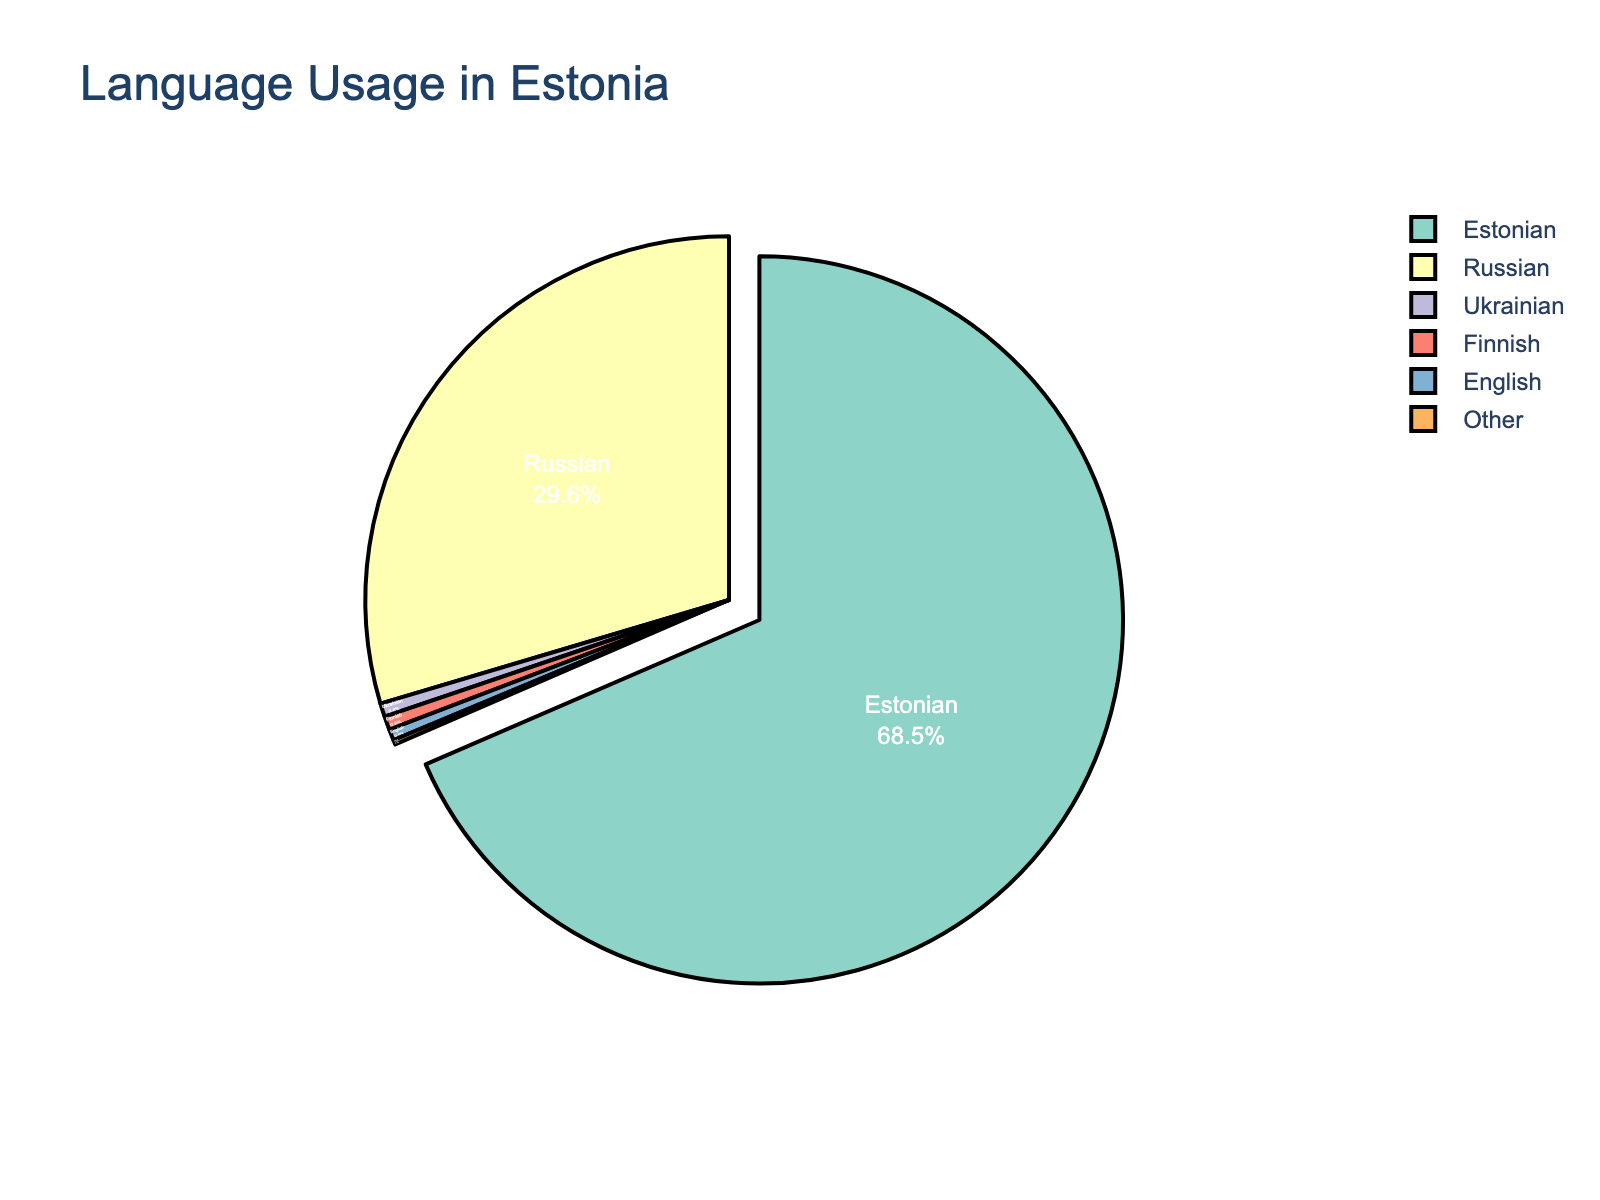What is the percentage of Estonian speakers in Estonia? Look for the section of the pie chart labeled "Estonian" and read the corresponding percentage
Answer: 68.5% Which language is the second most spoken in Estonia? Identify the language with the second largest portion in the pie chart after "Estonian"
Answer: Russian What is the combined percentage of languages other than Estonian and Russian spoken in Estonia? Sum the percentages of all sections labeled "Ukrainian," "Finnish," "English," and "Other": 0.6 + 0.6 + 0.5 + 0.2
Answer: 1.9% How much larger is the percentage of Estonian speakers compared to Russian speakers? Subtract the percentage of Russian speakers from the percentage of Estonian speakers: 68.5 - 29.6
Answer: 38.9% Which language has the smallest usage in Estonia and what is its percentage? Identify the smallest section in the pie chart and read the label and percentage
Answer: Other, 0.2% What is the total percentage of Estonian and Russian speakers combined? Add the percentages of Estonian and Russian speakers: 68.5 + 29.6
Answer: 98.1% Is the percentage of English speakers greater than the percentage of Finnish speakers? Compare the percentages of the sections labeled "English" and "Finnish"
Answer: No, both are 0.6% What is the visual attribute that differentiates the Estonian section from the other sections in the pie chart? Identify any unique visual attributes applied to the Estonian section (e.g., "pulled-out" or "highlight")
Answer: The Estonian section is pulled out If you were to exclude Estonian and Russian, which language has the highest percentage, and what is it? Look at the remaining segments not labeled "Estonian" or "Russian" and identify the one with the highest percentage
Answer: Ukrainian and Finnish, 0.6% 